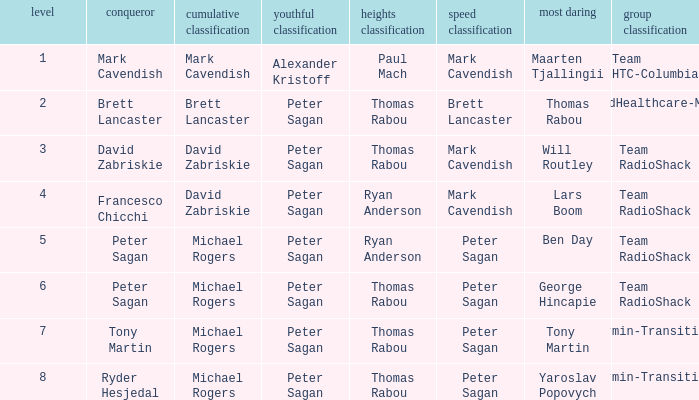In the same event where ryan anderson was victorious in the mountains classification and michael rogers took the general classification, who emerged as the winner of the sprint classification? Peter Sagan. 